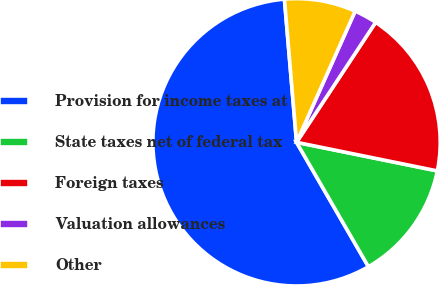Convert chart to OTSL. <chart><loc_0><loc_0><loc_500><loc_500><pie_chart><fcel>Provision for income taxes at<fcel>State taxes net of federal tax<fcel>Foreign taxes<fcel>Valuation allowances<fcel>Other<nl><fcel>56.99%<fcel>13.47%<fcel>18.91%<fcel>2.59%<fcel>8.03%<nl></chart> 